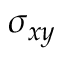<formula> <loc_0><loc_0><loc_500><loc_500>\sigma _ { x y }</formula> 